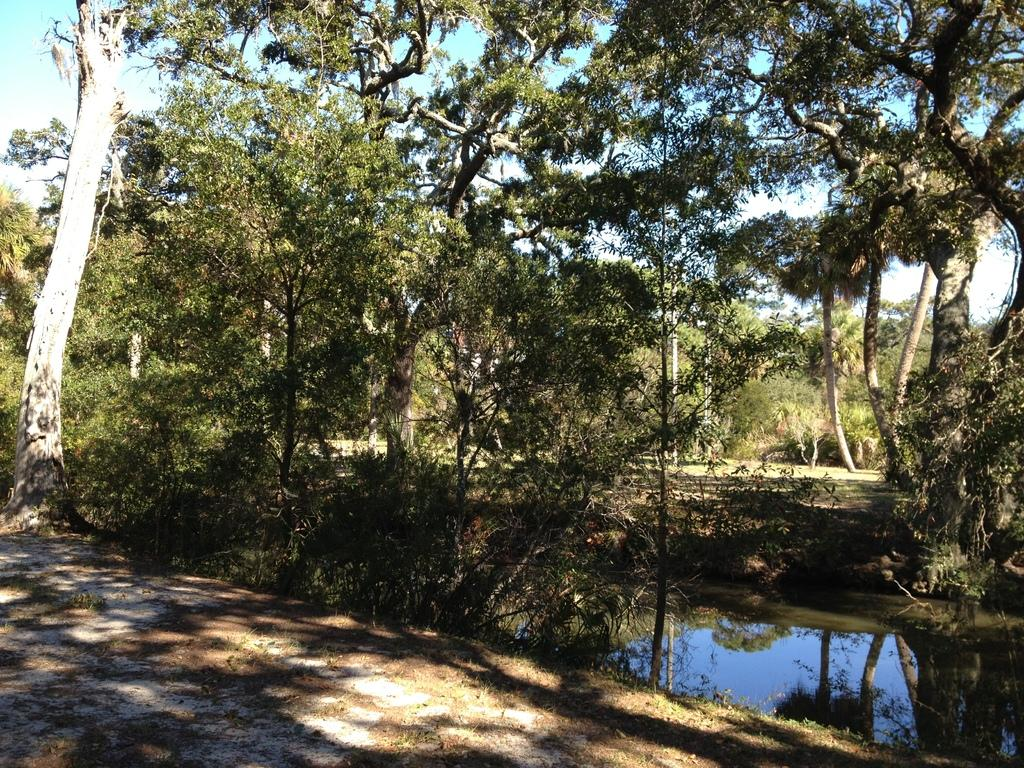What type of vegetation can be seen in the image? There are many trees in the image. What else can be seen between the trees? There is water visible between the trees. What is visible in the background of the image? The sky is visible in the background of the image. Where is the store located in the image? There is no store present in the image; it features trees, water, and the sky. Can you tell me how many times the mother exchanged words with her child in the image? There is no mother or child present in the image, as it only contains trees, water, and the sky. 